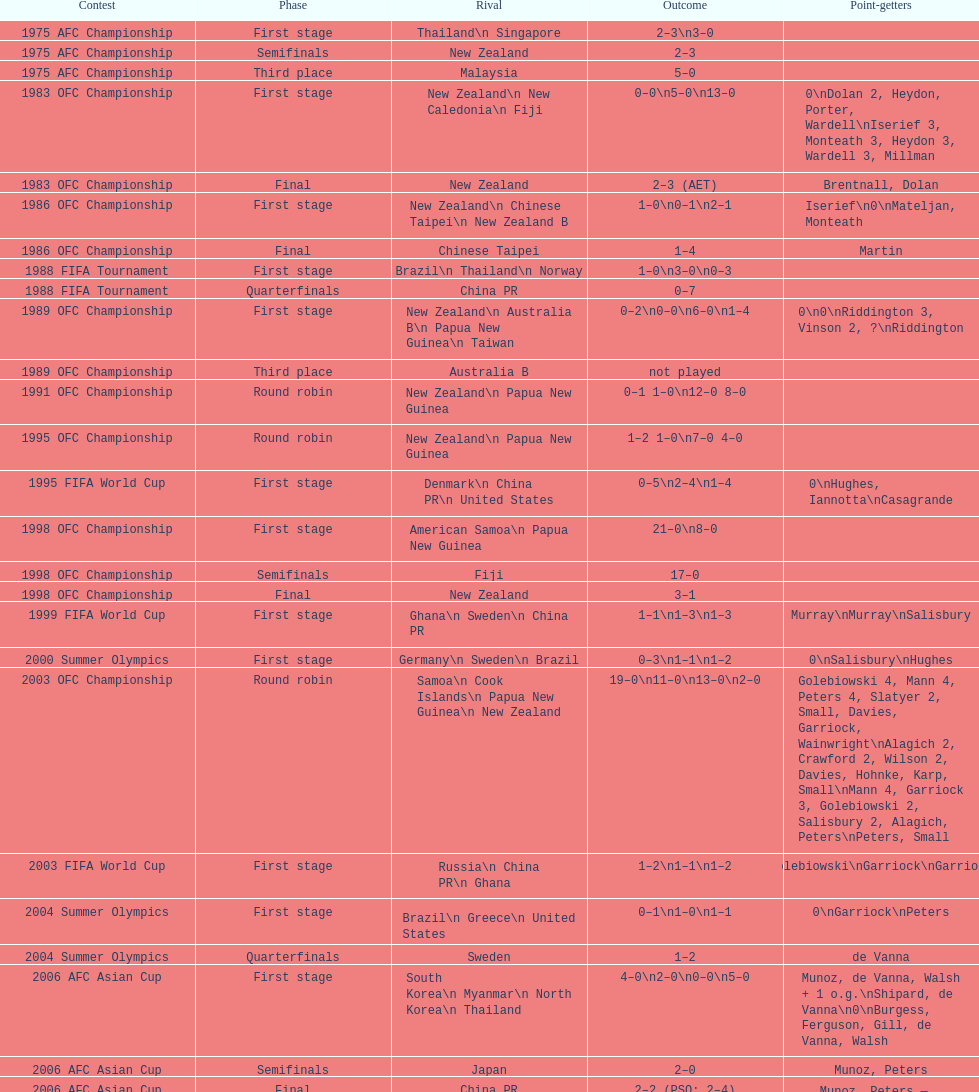What it the total number of countries in the first stage of the 2008 afc asian cup? 4. 